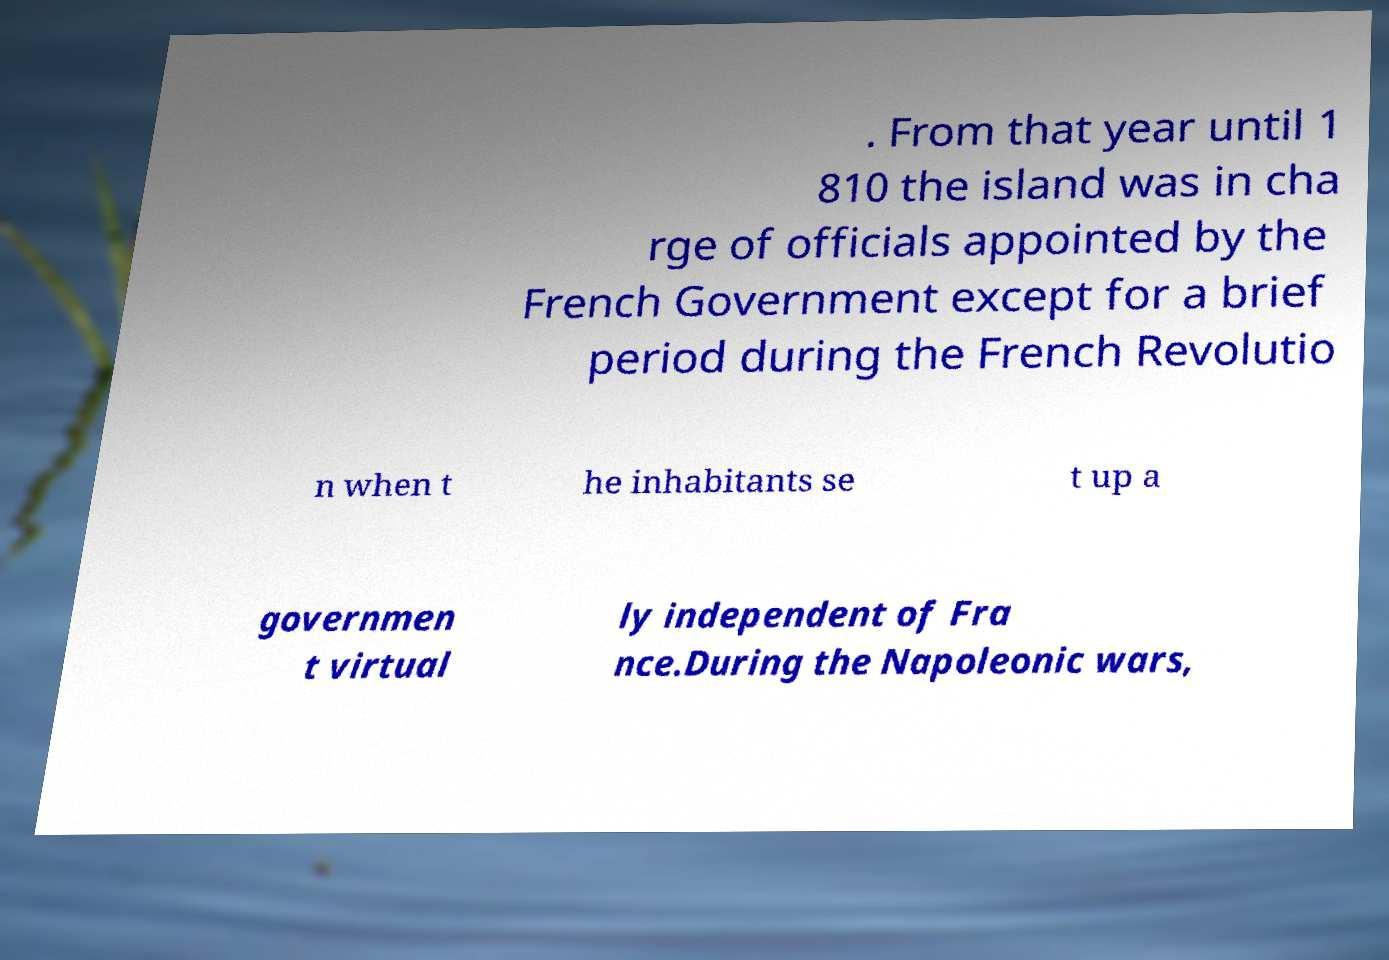For documentation purposes, I need the text within this image transcribed. Could you provide that? . From that year until 1 810 the island was in cha rge of officials appointed by the French Government except for a brief period during the French Revolutio n when t he inhabitants se t up a governmen t virtual ly independent of Fra nce.During the Napoleonic wars, 